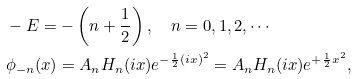<formula> <loc_0><loc_0><loc_500><loc_500>& - E = - \left ( n + \frac { 1 } { 2 } \right ) , \quad n = 0 , 1 , 2 , \cdots \\ & \phi _ { - n } ( x ) = A _ { n } H _ { n } ( i x ) e ^ { - \frac { 1 } { 2 } ( i x ) ^ { 2 } } = A _ { n } H _ { n } ( i x ) e ^ { + \frac { 1 } { 2 } x ^ { 2 } } ,</formula> 